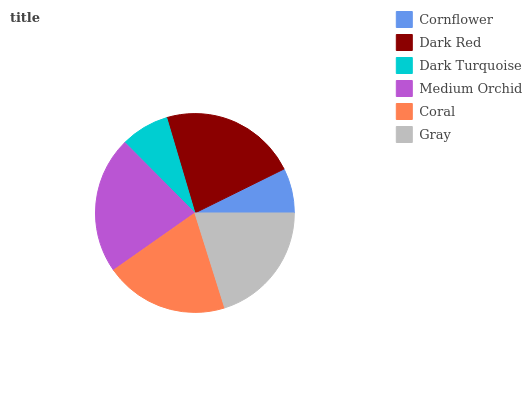Is Cornflower the minimum?
Answer yes or no. Yes. Is Medium Orchid the maximum?
Answer yes or no. Yes. Is Dark Red the minimum?
Answer yes or no. No. Is Dark Red the maximum?
Answer yes or no. No. Is Dark Red greater than Cornflower?
Answer yes or no. Yes. Is Cornflower less than Dark Red?
Answer yes or no. Yes. Is Cornflower greater than Dark Red?
Answer yes or no. No. Is Dark Red less than Cornflower?
Answer yes or no. No. Is Gray the high median?
Answer yes or no. Yes. Is Coral the low median?
Answer yes or no. Yes. Is Dark Red the high median?
Answer yes or no. No. Is Medium Orchid the low median?
Answer yes or no. No. 